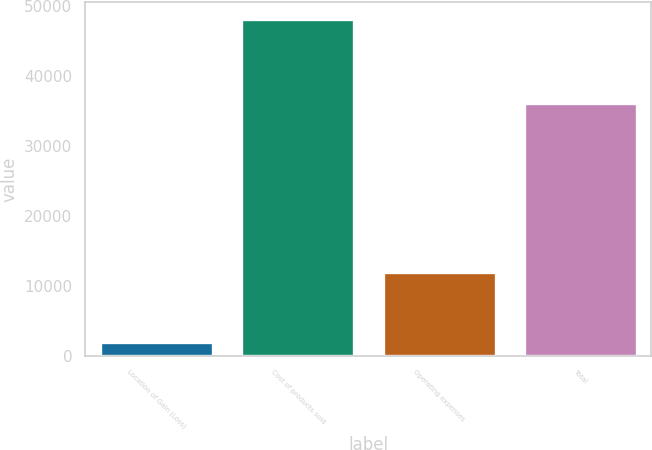Convert chart to OTSL. <chart><loc_0><loc_0><loc_500><loc_500><bar_chart><fcel>Location of Gain (Loss)<fcel>Cost of products sold<fcel>Operating expenses<fcel>Total<nl><fcel>2015<fcel>48082<fcel>12003<fcel>36079<nl></chart> 